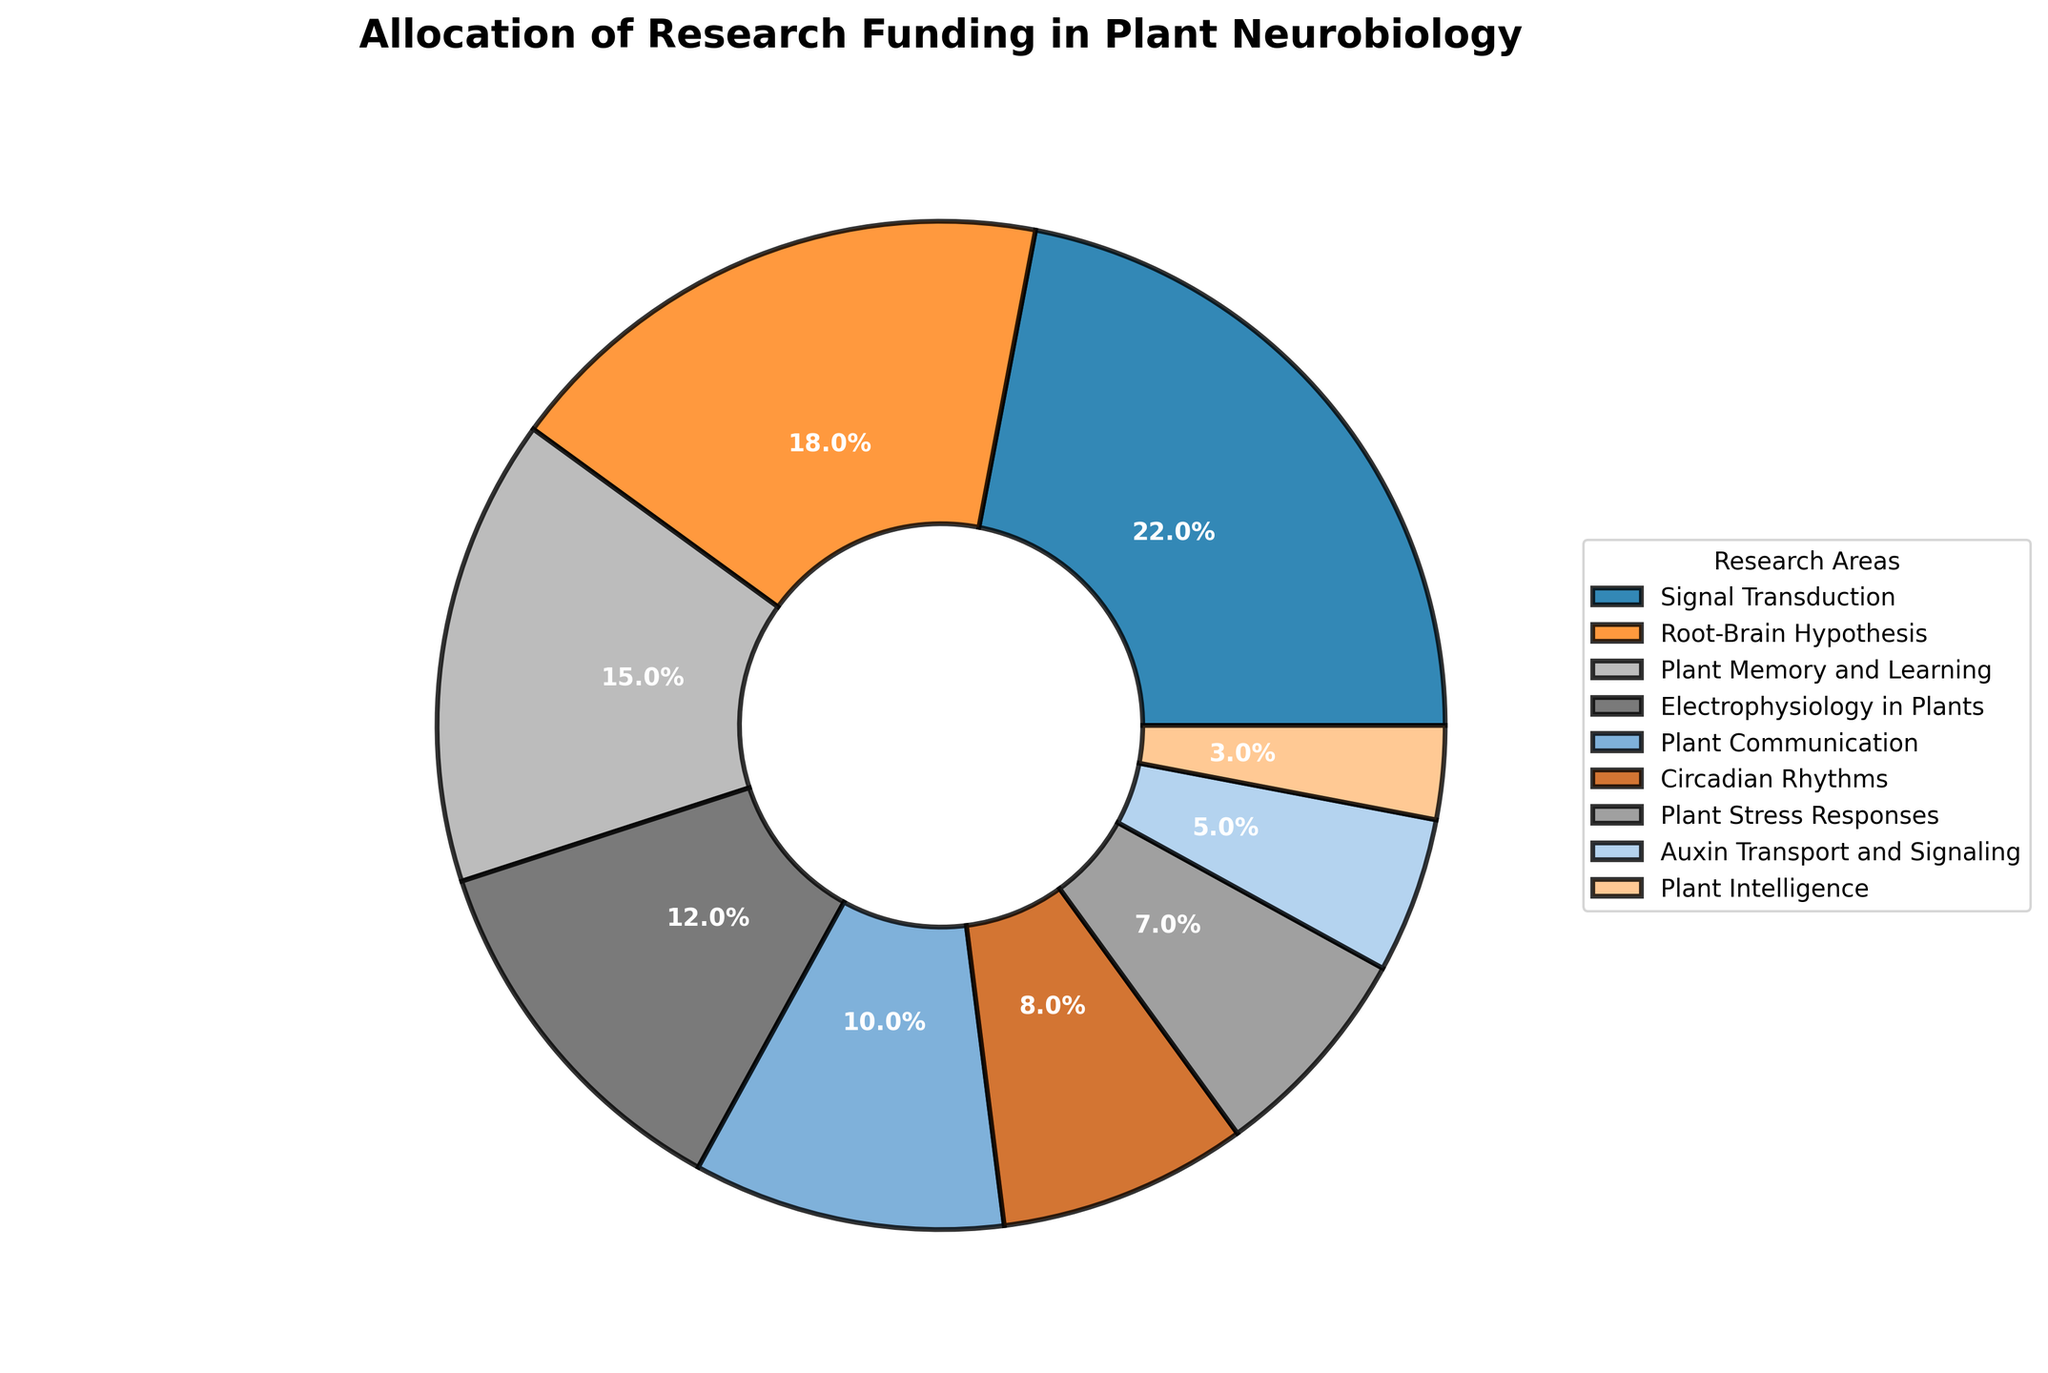What percentage of the research funding is allocated to the Root-Brain Hypothesis and Plant Communication combined? To find the combined percentage, you add the funding percentages for Root-Brain Hypothesis (18%) and Plant Communication (10%). So, 18 + 10 = 28.
Answer: 28% Which research area has received the least funding? By comparing the given percentages, we see that Plant Intelligence received the lowest funding, which is 3%.
Answer: Plant Intelligence Is the funding for Auxin Transport and Signaling greater than Plant Stress Responses? Examine the funding percentages for both areas: Auxin Transport and Signaling is 5%, while Plant Stress Responses is 7%. Since 5% is less than 7%, the funding for Auxin Transport and Signaling is not greater.
Answer: No What is the difference in funding percentage between Electrophysiology in Plants and Circadian Rhythms? To find the difference, subtract the funding percentage of Circadian Rhythms (8%) from Electrophysiology in Plants (12%). So, 12 - 8 = 4.
Answer: 4% What percentage of the total funding is allocated to Plant Memory and Learning, and Electrophysiology in Plants combined? Add the funding percentages for Plant Memory and Learning (15%) and Electrophysiology in Plants (12%). So, 15 + 12 = 27.
Answer: 27% Which research area receives more funding: Signal Transduction or Root-Brain Hypothesis? Compare the funding percentages: Signal Transduction receives 22%, while Root-Brain Hypothesis receives 18%. Since 22% is greater than 18%, Signal Transduction receives more funding.
Answer: Signal Transduction What is the combined funding percentage for Signal Transduction, Plant Stress Responses, and Plant Intelligence? Add the funding percentages for the three areas. Signal Transduction is 22%, Plant Stress Responses is 7%, and Plant Intelligence is 3%. So, 22 + 7 + 3 = 32.
Answer: 32% Among the research areas, which two have the closest funding percentages? Compare the percentages and find the smallest difference. The closest are Electrophysiology in Plants (12%) and Plant Communication (10%) with a difference of 2%.
Answer: Electrophysiology in Plants and Plant Communication What percentage of funding does Plant Communication receive relative to Signal Transduction? To find this relative percentage, divide the funding percentage of Plant Communication (10%) by that of Signal Transduction (22%) and multiply by 100. So, (10 / 22) * 100 ≈ 45.45.
Answer: 45.45% If the funding for Plant Memory and Learning were increased by 5%, what would its new funding percentage be? Add 5% to the current funding percentage of Plant Memory and Learning (15%). So, 15 + 5 = 20.
Answer: 20% 